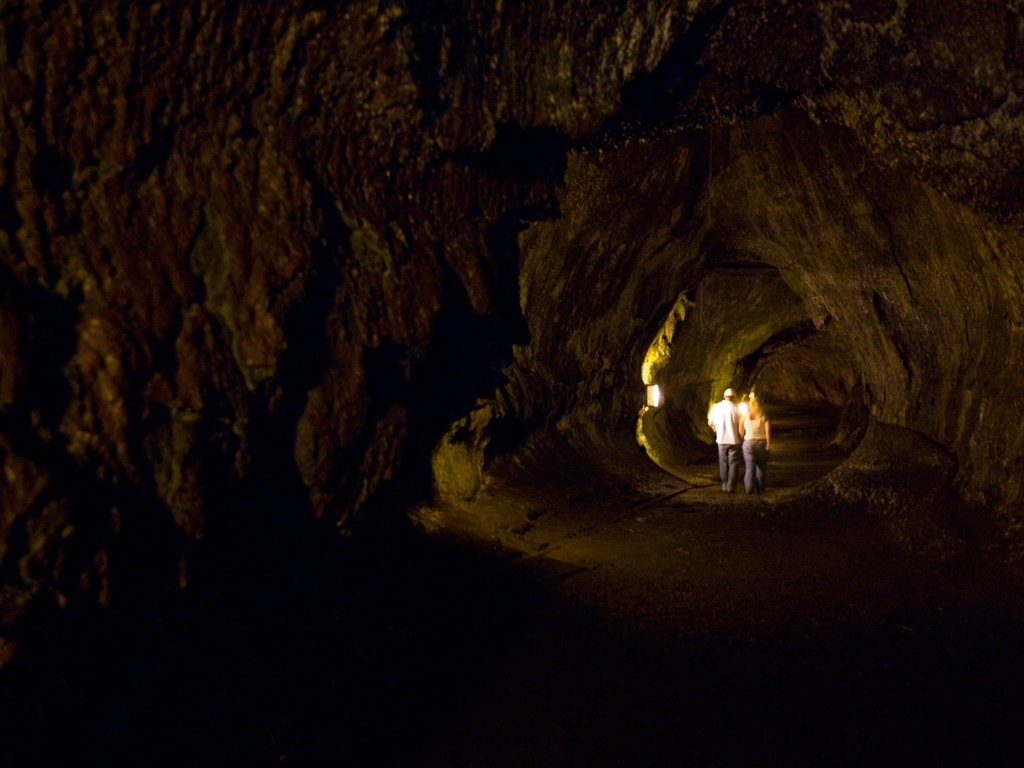Is the lighting in the image dim?
A. No
B. Yes
Answer with the option's letter from the given choices directly.
 B. 